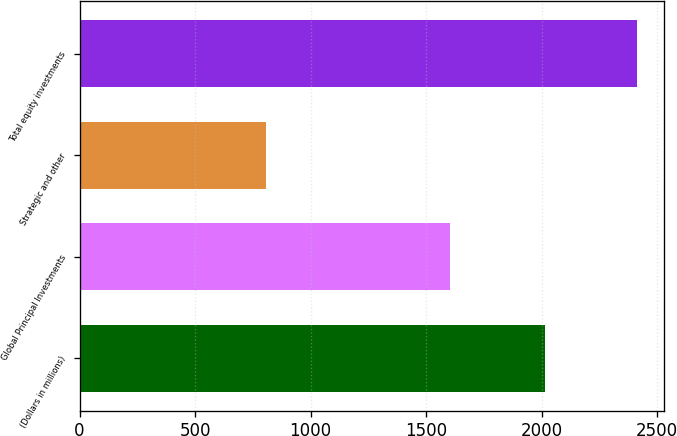<chart> <loc_0><loc_0><loc_500><loc_500><bar_chart><fcel>(Dollars in millions)<fcel>Global Principal Investments<fcel>Strategic and other<fcel>Total equity investments<nl><fcel>2013<fcel>1604<fcel>807<fcel>2411<nl></chart> 